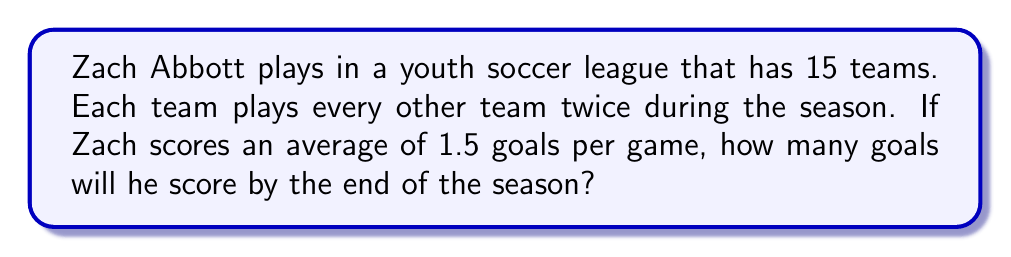Could you help me with this problem? Let's break this down step-by-step:

1) First, we need to calculate the total number of games Zach will play in the season.

   - There are 15 teams in the league.
   - Each team plays every other team twice.
   - Zach's team will play against 14 other teams (all teams except their own).

   So, the number of games Zach's team will play is:
   $$ 14 \times 2 = 28 \text{ games} $$

2) Now that we know the number of games, we can calculate Zach's total goals:

   - Zach scores an average of 1.5 goals per game.
   - He will play 28 games.

   To calculate the total goals, we multiply:
   $$ 1.5 \text{ goals/game} \times 28 \text{ games} = 42 \text{ goals} $$

Therefore, by the end of the season, Zach will score 42 goals.
Answer: 42 goals 